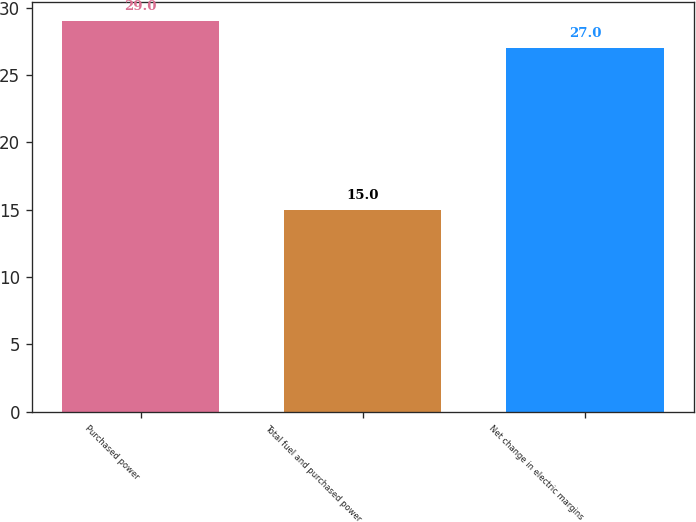<chart> <loc_0><loc_0><loc_500><loc_500><bar_chart><fcel>Purchased power<fcel>Total fuel and purchased power<fcel>Net change in electric margins<nl><fcel>29<fcel>15<fcel>27<nl></chart> 